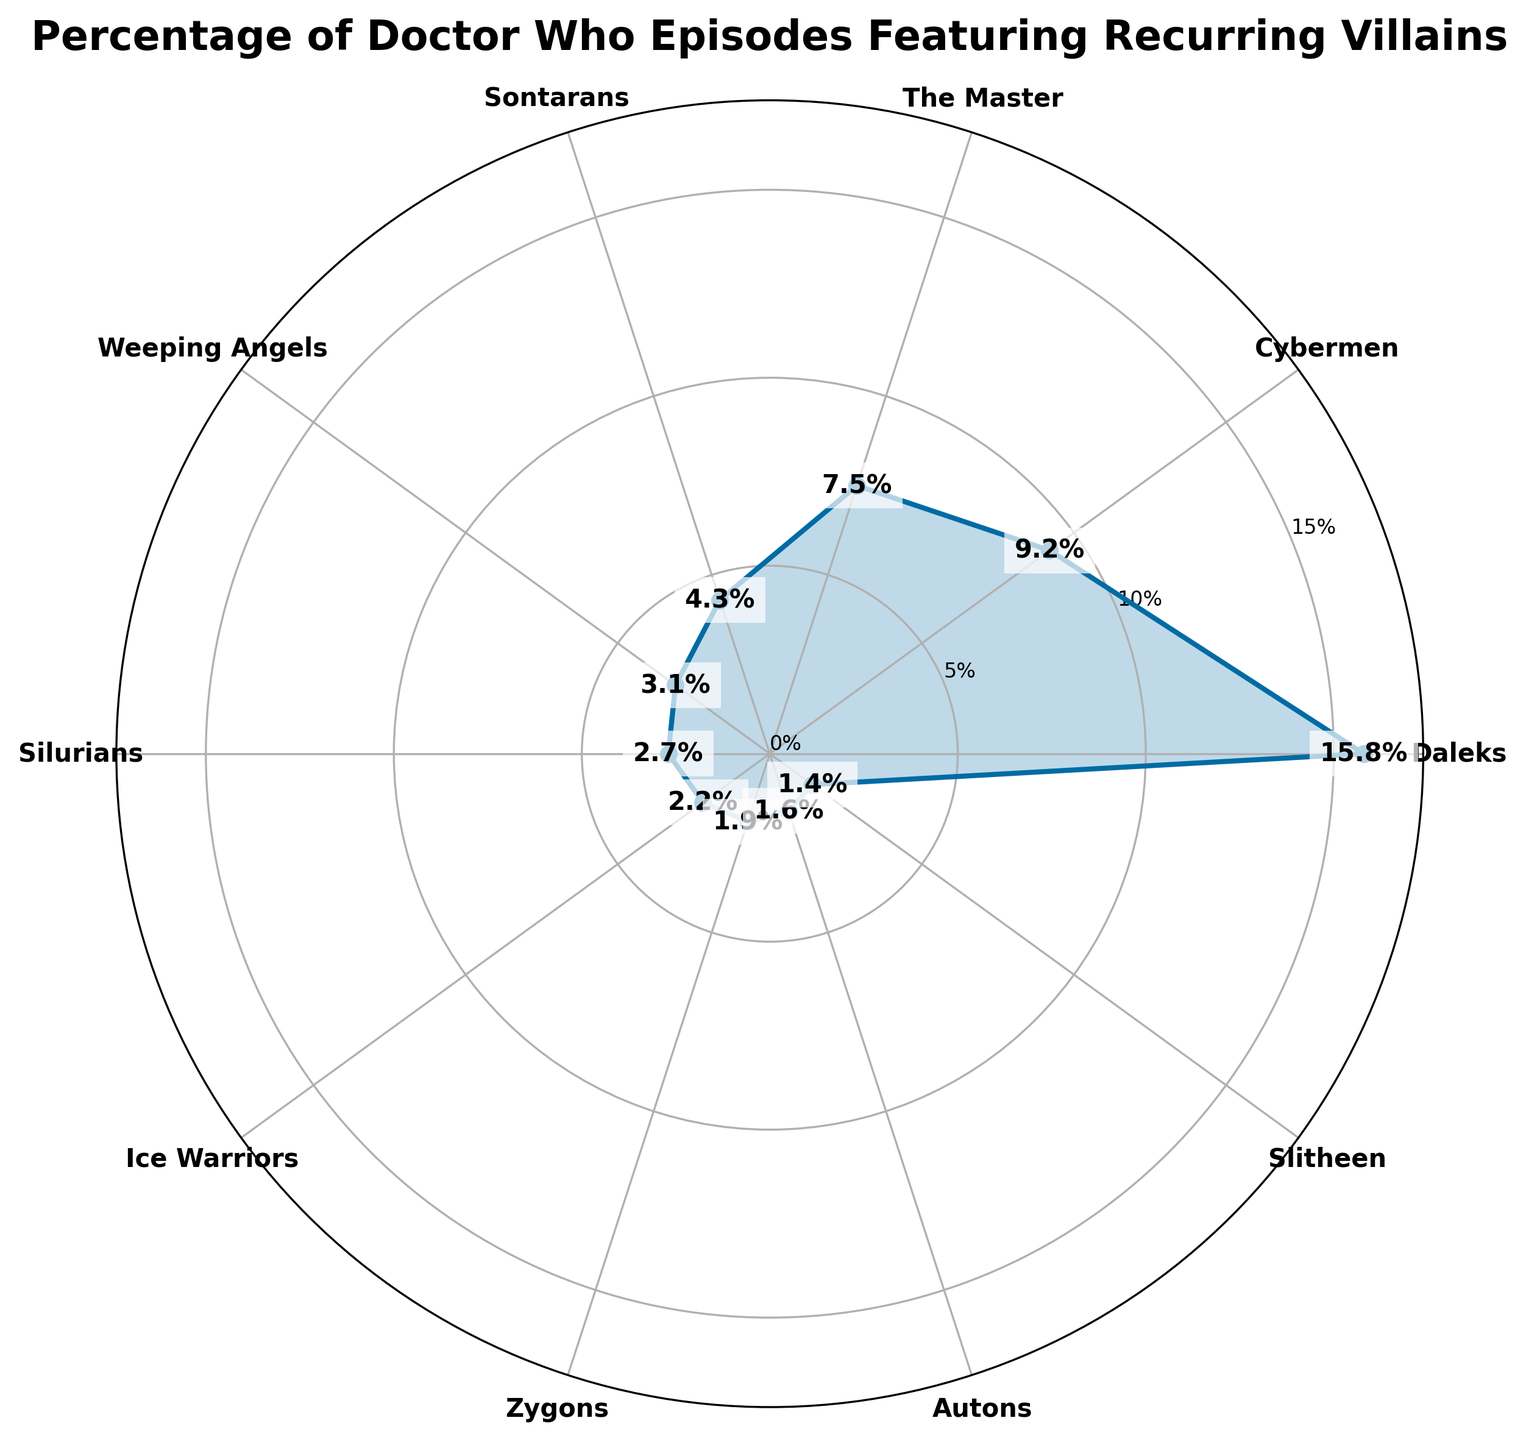What is the title of the plot? The title of the plot is displayed at the top center, reading "Percentage of Doctor Who Episodes Featuring Recurring Villains."
Answer: Percentage of Doctor Who Episodes Featuring Recurring Villains How many villains are displayed on the plot? The plot shows data points for each villain along the circular axis. By counting these labels, we can see there are ten villains listed.
Answer: Ten Which villain has the highest percentage of episodes? By examining the data points and the labels, the Daleks have the highest percentage, shown at the pinnacle of the plot at 15.8%.
Answer: Daleks Which villain is featured in 4.3% of Doctor Who episodes? Observing the labels and their corresponding percentages, the Sontarans are shown at the 4.3% mark.
Answer: Sontarans How does the percentage of episodes featuring the Cybermen compare to that of The Master? The Cybermen appear in 9.2% of episodes while The Master appears in 7.5%, making the Cybermen's percentage higher.
Answer: Cybermen have a higher percentage What is the combined percentage of episodes featuring the Weeping Angels, Silurians, and Ice Warriors? Summing up the percentages from the plot (3.1% + 2.7% + 2.2%), the total combined percentage is 8.0%.
Answer: 8.0% What is the difference in percentage between episodes featuring the Zygons and the Autons? By subtracting the Autons' percentage (1.6%) from the Zygons' percentage (1.9%), the difference is 0.3%.
Answer: 0.3% What percentage is visually closest to 10% on the plot? None of the villains reach exactly 10%, but by observing the data points, Cybermen at 9.2% are the closest to 10%.
Answer: Cybermen What percentage range does the y-axis cover? The y-axis uses labels to indicate percentage intervals. It starts at 0% and reaches just slightly above the highest data point (15.8%), so it spans from 0% to around 16-17%.
Answer: 0% - 16% Which villains have a percentage below 2%? Observing the data points, the villains with a percentage below 2% are the Autons (1.6%) and the Slitheen (1.4%).
Answer: Autons and Slitheen 